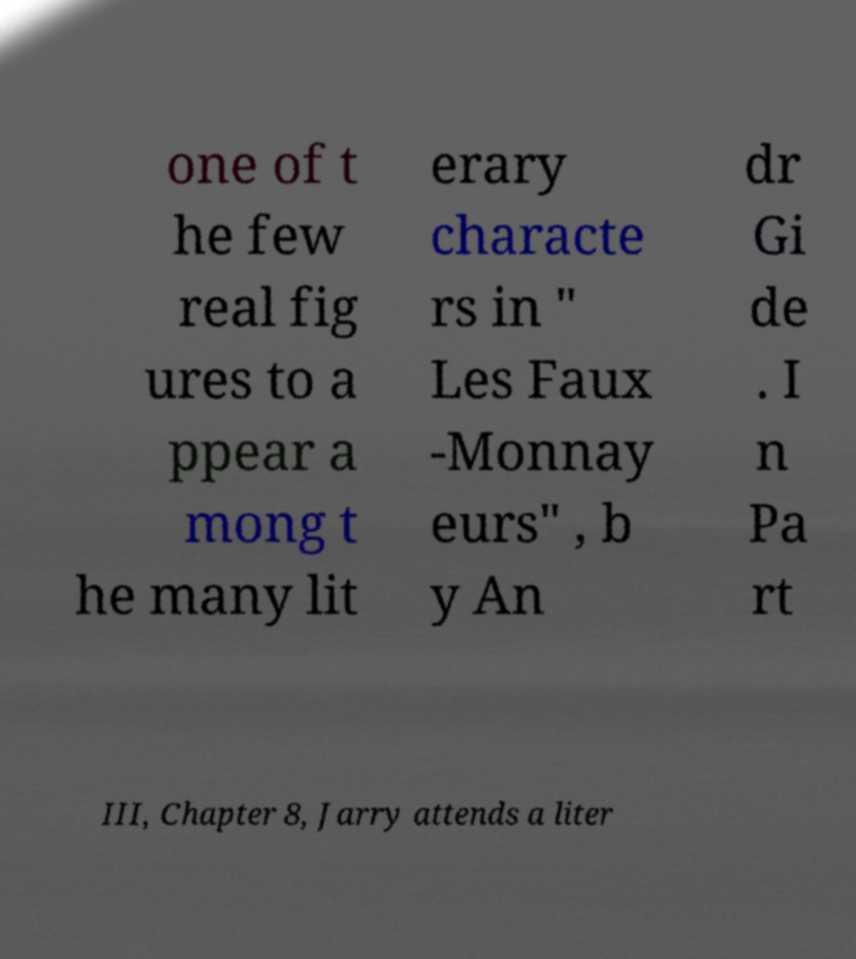I need the written content from this picture converted into text. Can you do that? one of t he few real fig ures to a ppear a mong t he many lit erary characte rs in " Les Faux -Monnay eurs" , b y An dr Gi de . I n Pa rt III, Chapter 8, Jarry attends a liter 